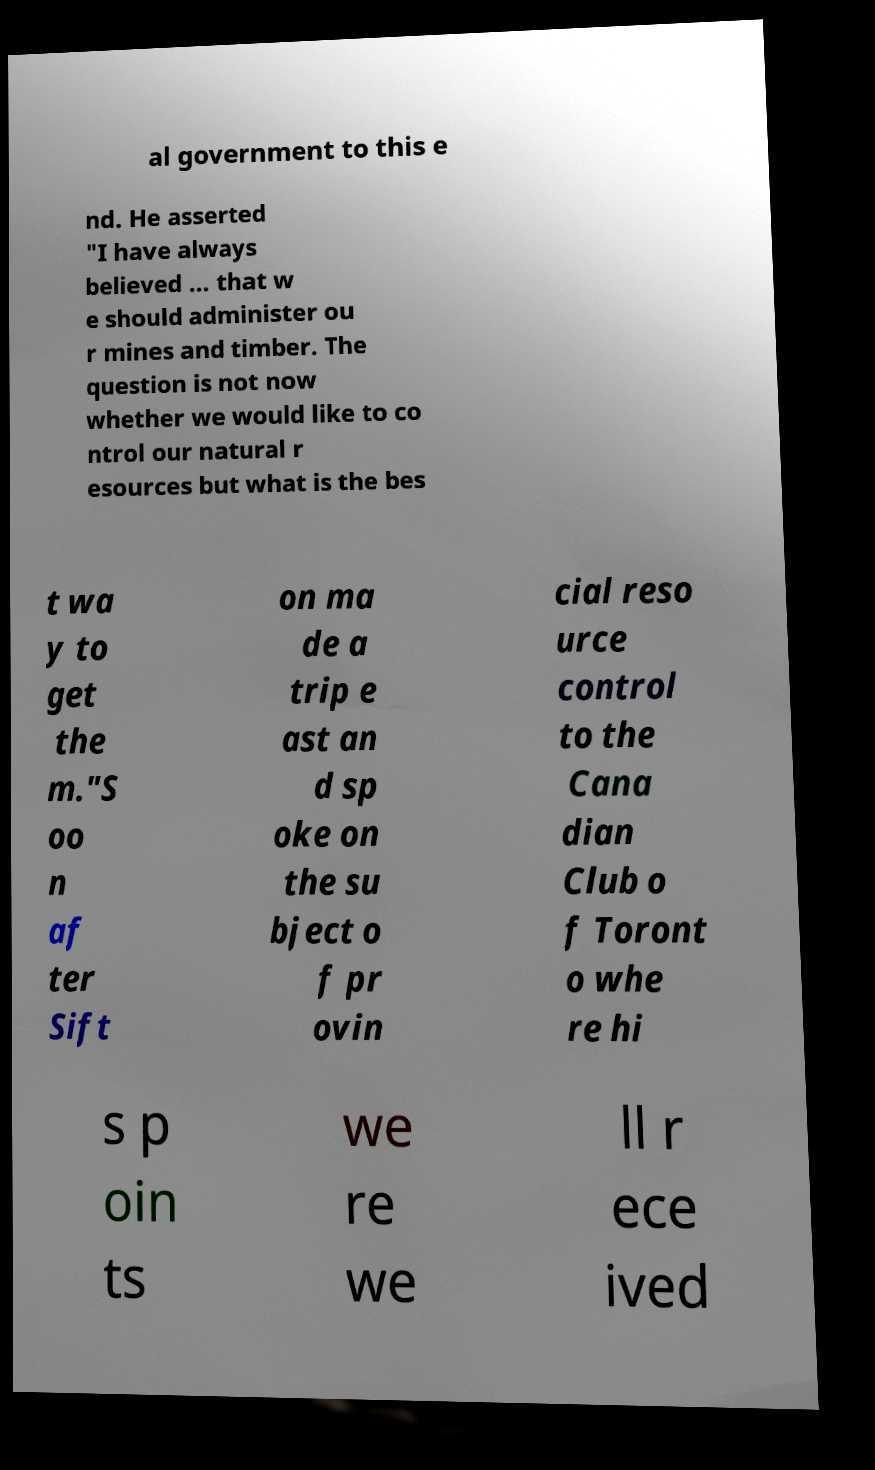There's text embedded in this image that I need extracted. Can you transcribe it verbatim? al government to this e nd. He asserted "I have always believed ... that w e should administer ou r mines and timber. The question is not now whether we would like to co ntrol our natural r esources but what is the bes t wa y to get the m."S oo n af ter Sift on ma de a trip e ast an d sp oke on the su bject o f pr ovin cial reso urce control to the Cana dian Club o f Toront o whe re hi s p oin ts we re we ll r ece ived 